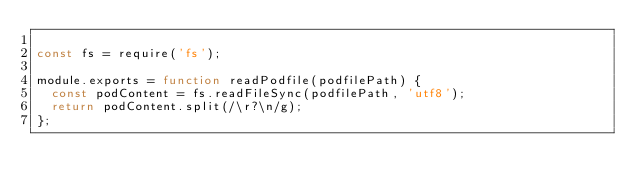Convert code to text. <code><loc_0><loc_0><loc_500><loc_500><_JavaScript_>
const fs = require('fs');

module.exports = function readPodfile(podfilePath) {
  const podContent = fs.readFileSync(podfilePath, 'utf8');
  return podContent.split(/\r?\n/g);
};
</code> 